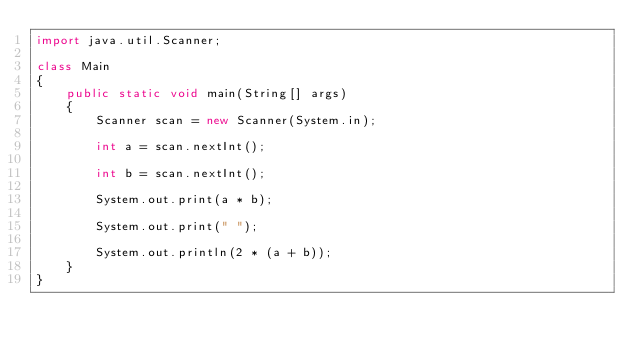<code> <loc_0><loc_0><loc_500><loc_500><_Java_>import java.util.Scanner;

class Main
{
    public static void main(String[] args)
    {
        Scanner scan = new Scanner(System.in);
        
        int a = scan.nextInt();
        
        int b = scan.nextInt();
        
        System.out.print(a * b);
        
        System.out.print(" ");

        System.out.println(2 * (a + b));
    }
}
</code> 